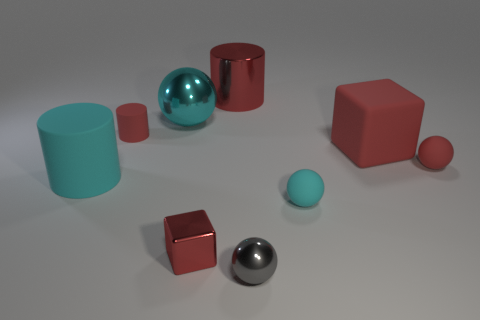Subtract all large cylinders. How many cylinders are left? 1 Subtract all cyan cylinders. How many cylinders are left? 2 Subtract 3 cylinders. How many cylinders are left? 0 Subtract all small cyan rubber things. Subtract all large red things. How many objects are left? 6 Add 5 small red balls. How many small red balls are left? 6 Add 8 brown rubber objects. How many brown rubber objects exist? 8 Subtract 0 green cubes. How many objects are left? 9 Subtract all cubes. How many objects are left? 7 Subtract all gray balls. Subtract all red cylinders. How many balls are left? 3 Subtract all blue spheres. How many purple cubes are left? 0 